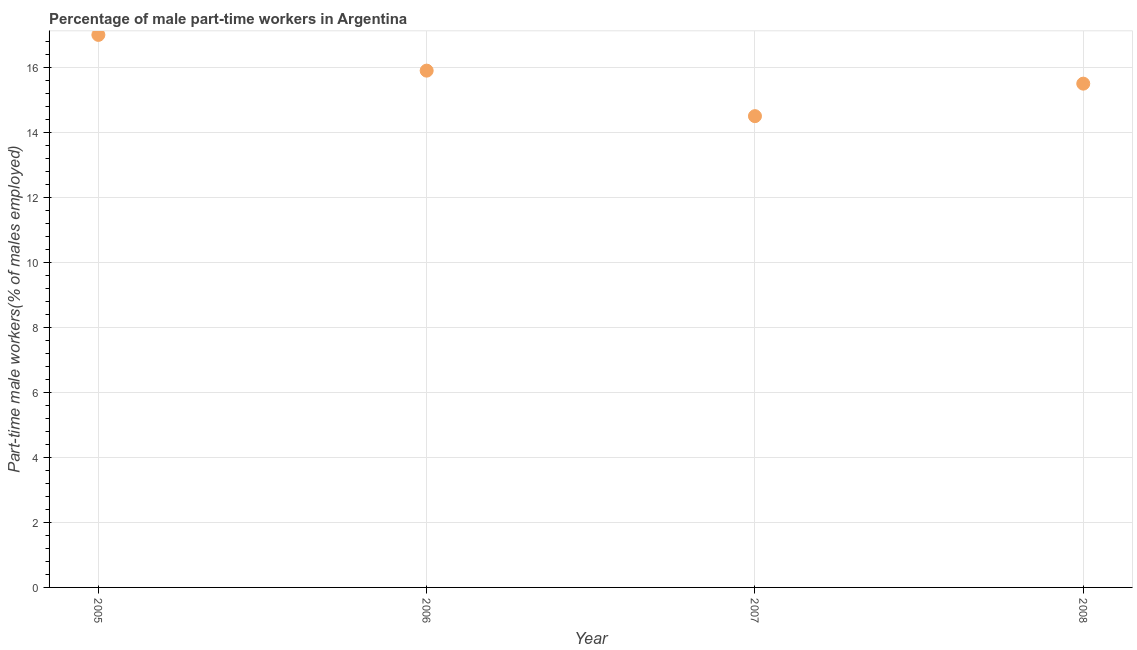What is the percentage of part-time male workers in 2006?
Keep it short and to the point. 15.9. Across all years, what is the maximum percentage of part-time male workers?
Ensure brevity in your answer.  17. What is the sum of the percentage of part-time male workers?
Make the answer very short. 62.9. What is the difference between the percentage of part-time male workers in 2006 and 2007?
Ensure brevity in your answer.  1.4. What is the average percentage of part-time male workers per year?
Give a very brief answer. 15.72. What is the median percentage of part-time male workers?
Ensure brevity in your answer.  15.7. In how many years, is the percentage of part-time male workers greater than 10 %?
Keep it short and to the point. 4. What is the ratio of the percentage of part-time male workers in 2006 to that in 2008?
Keep it short and to the point. 1.03. Is the percentage of part-time male workers in 2005 less than that in 2006?
Give a very brief answer. No. Is the difference between the percentage of part-time male workers in 2005 and 2008 greater than the difference between any two years?
Give a very brief answer. No. What is the difference between the highest and the second highest percentage of part-time male workers?
Give a very brief answer. 1.1. Is the sum of the percentage of part-time male workers in 2006 and 2007 greater than the maximum percentage of part-time male workers across all years?
Your answer should be very brief. Yes. What is the difference between the highest and the lowest percentage of part-time male workers?
Offer a terse response. 2.5. In how many years, is the percentage of part-time male workers greater than the average percentage of part-time male workers taken over all years?
Your answer should be very brief. 2. How many years are there in the graph?
Provide a short and direct response. 4. What is the difference between two consecutive major ticks on the Y-axis?
Your response must be concise. 2. Are the values on the major ticks of Y-axis written in scientific E-notation?
Ensure brevity in your answer.  No. What is the title of the graph?
Offer a very short reply. Percentage of male part-time workers in Argentina. What is the label or title of the Y-axis?
Give a very brief answer. Part-time male workers(% of males employed). What is the Part-time male workers(% of males employed) in 2005?
Offer a terse response. 17. What is the Part-time male workers(% of males employed) in 2006?
Keep it short and to the point. 15.9. What is the Part-time male workers(% of males employed) in 2008?
Make the answer very short. 15.5. What is the difference between the Part-time male workers(% of males employed) in 2005 and 2007?
Make the answer very short. 2.5. What is the difference between the Part-time male workers(% of males employed) in 2006 and 2007?
Provide a short and direct response. 1.4. What is the difference between the Part-time male workers(% of males employed) in 2006 and 2008?
Ensure brevity in your answer.  0.4. What is the ratio of the Part-time male workers(% of males employed) in 2005 to that in 2006?
Offer a very short reply. 1.07. What is the ratio of the Part-time male workers(% of males employed) in 2005 to that in 2007?
Provide a short and direct response. 1.17. What is the ratio of the Part-time male workers(% of males employed) in 2005 to that in 2008?
Offer a terse response. 1.1. What is the ratio of the Part-time male workers(% of males employed) in 2006 to that in 2007?
Make the answer very short. 1.1. What is the ratio of the Part-time male workers(% of males employed) in 2007 to that in 2008?
Ensure brevity in your answer.  0.94. 